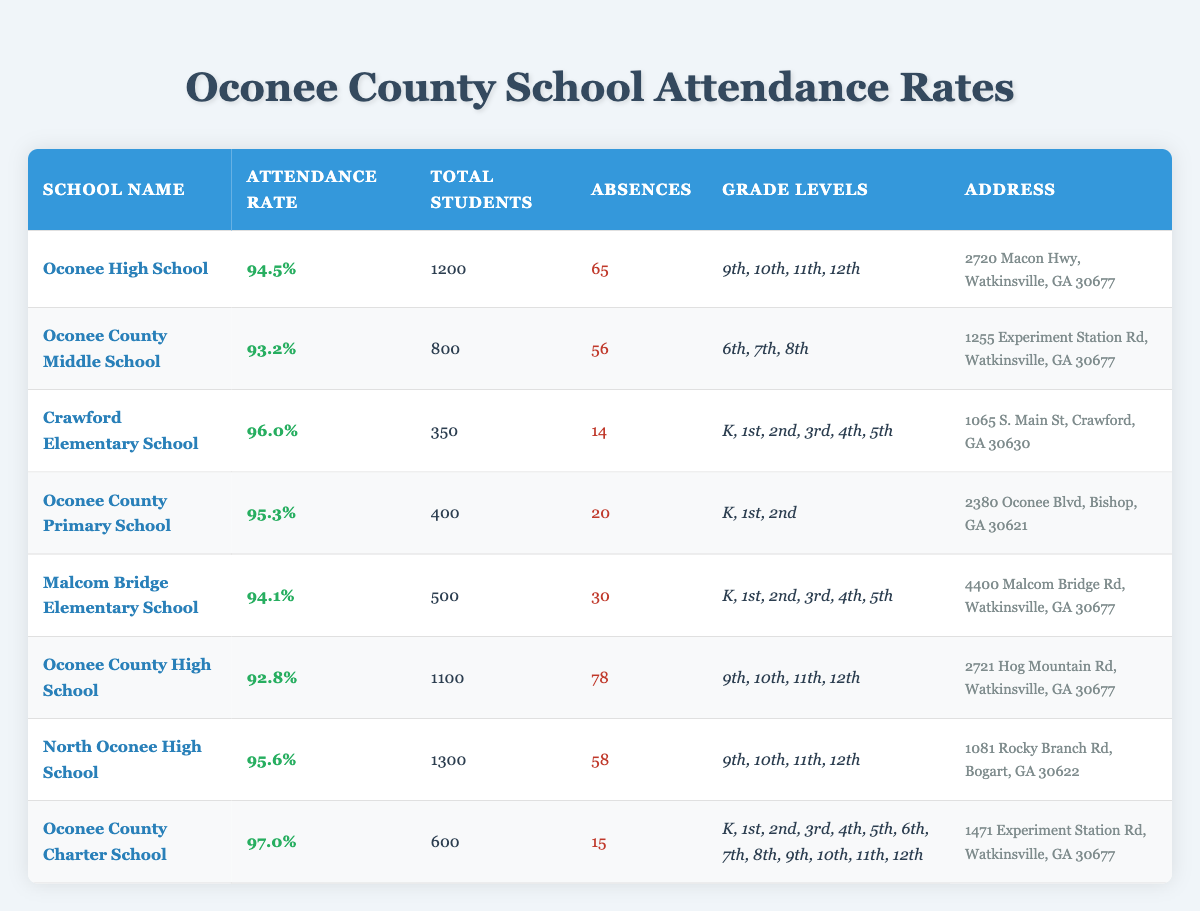What is the attendance rate for Oconee County High School? The attendance rate for Oconee County High School is listed directly in the table under the "Attendance Rate" column, next to the school's name.
Answer: 92.8% Which school has the highest attendance rate? To find out which school has the highest attendance rate, I can look through the "Attendance Rate" column and identify the maximum value. North Oconee High School has an attendance rate of 95.6%, which is higher than all others.
Answer: North Oconee High School How many students are enrolled in Crawford Elementary School? The total number of students enrolled in Crawford Elementary School is provided in the "Total Students" column next to the school’s name. It shows that there are 350 students.
Answer: 350 What is the average attendance rate of all schools listed? First, I will sum up the attendance rates of all schools: (94.5 + 93.2 + 96.0 + 95.3 + 94.1 + 92.8 + 95.6 + 97.0) =  763.5. There are 8 schools total, so the average is 763.5 / 8 = 95.44.
Answer: 95.44 Is the number of absences at Malcom Bridge Elementary School greater than that at Oconee County Primary School? Malcom Bridge Elementary School has 30 absences while Oconee County Primary School has 20. Since 30 is greater than 20, the answer is yes.
Answer: Yes What is the total number of students across all schools? I need to sum the total number of students in each school. Adding them together: 1200 + 800 + 350 + 400 + 500 + 1100 + 1300 + 600 = 5250.
Answer: 5250 Are there more students in Oconee High School than in Malcom Bridge Elementary School? The number of students in Oconee High School is 1200, while in Malcom Bridge Elementary School, it is 500. Since 1200 is greater than 500, the answer is yes.
Answer: Yes Which school has fewer absences, Oconee County Charter School or North Oconee High School? Oconee County Charter School has 15 absences while North Oconee High School has 58 absences. Since 15 is fewer than 58, the answer is Oconee County Charter School.
Answer: Oconee County Charter School What is the percentage difference in attendance rates between Crawford Elementary School and Oconee County Middle School? The attendance rate for Crawford Elementary School is 96.0%, and for Oconee County Middle School, it is 93.2%. The difference is 96.0 - 93.2 = 2.8. To find the percentage difference, I divide the difference by Oconee County Middle School's rate and multiply by 100: (2.8 / 93.2) * 100 ≈ 3.00%.
Answer: 3.00% 